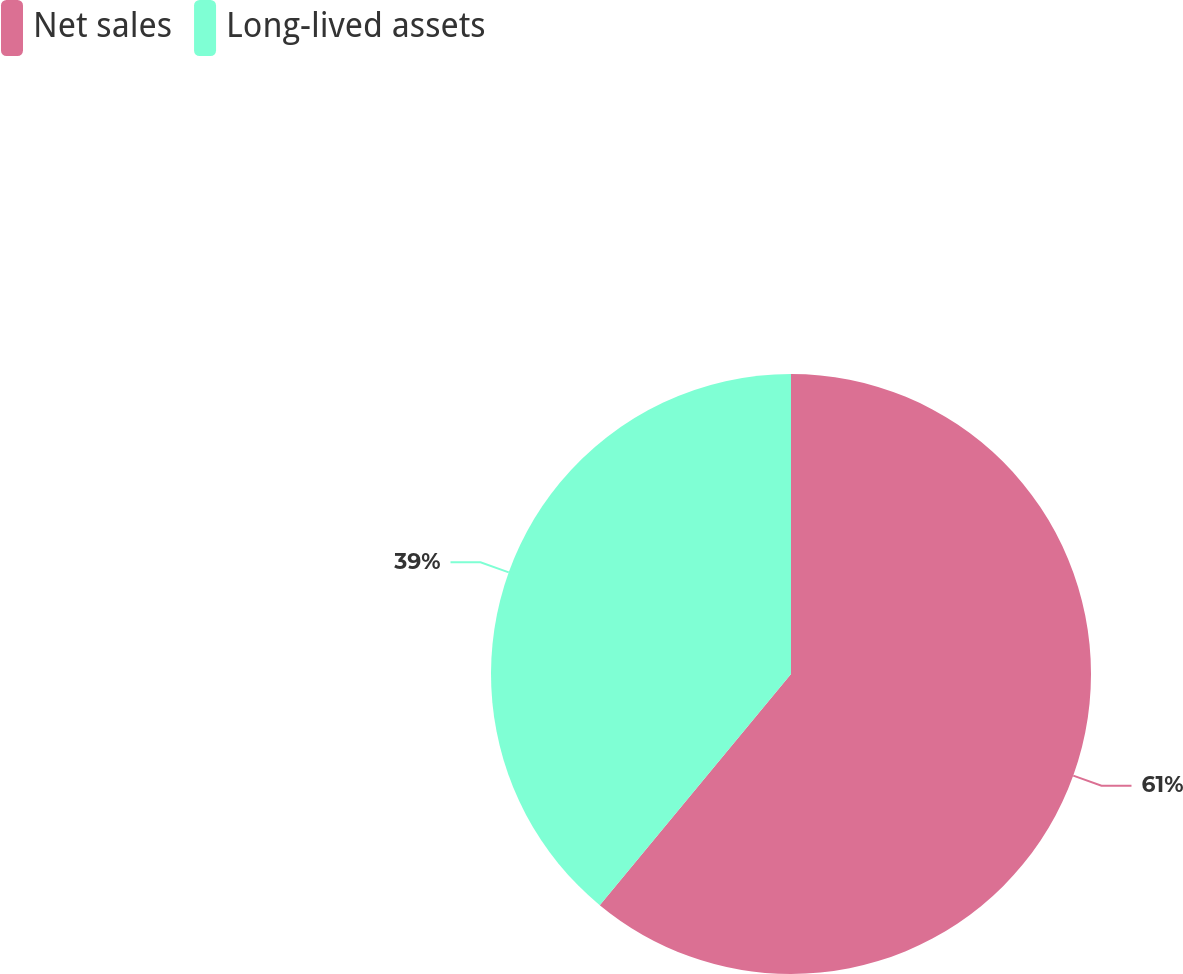<chart> <loc_0><loc_0><loc_500><loc_500><pie_chart><fcel>Net sales<fcel>Long-lived assets<nl><fcel>61.0%<fcel>39.0%<nl></chart> 